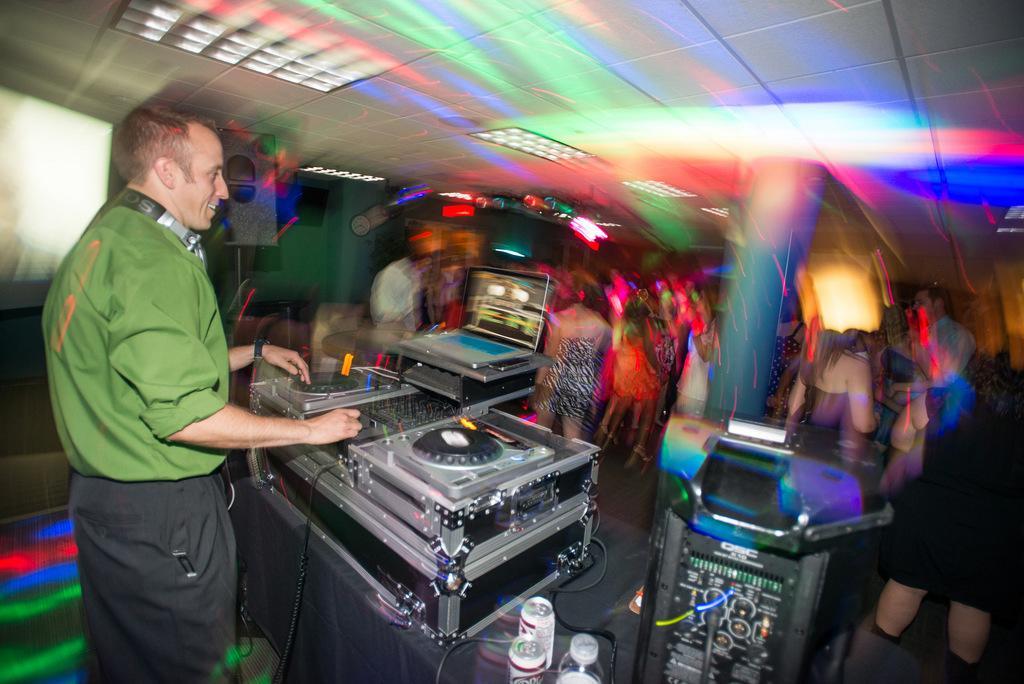How would you summarize this image in a sentence or two? In this picture we can see a group of people on the floor, laptop, speakers, tins, bottle, wires and a man standing and smiling and in the background we can see lights and it is blurry. 